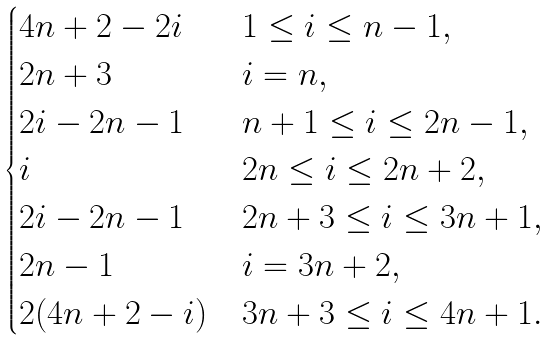<formula> <loc_0><loc_0><loc_500><loc_500>\begin{cases} 4 n + 2 - 2 i & 1 \leq i \leq n - 1 , \\ 2 n + 3 & i = n , \\ 2 i - 2 n - 1 & n + 1 \leq i \leq 2 n - 1 , \\ i & 2 n \leq i \leq 2 n + 2 , \\ 2 i - 2 n - 1 & 2 n + 3 \leq i \leq 3 n + 1 , \\ 2 n - 1 & i = 3 n + 2 , \\ 2 ( 4 n + 2 - i ) & 3 n + 3 \leq i \leq 4 n + 1 . \end{cases}</formula> 